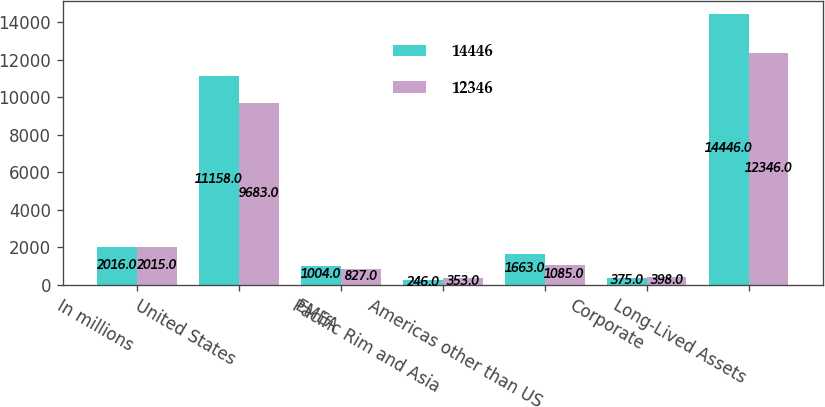Convert chart to OTSL. <chart><loc_0><loc_0><loc_500><loc_500><stacked_bar_chart><ecel><fcel>In millions<fcel>United States<fcel>EMEA<fcel>Pacific Rim and Asia<fcel>Americas other than US<fcel>Corporate<fcel>Long-Lived Assets<nl><fcel>14446<fcel>2016<fcel>11158<fcel>1004<fcel>246<fcel>1663<fcel>375<fcel>14446<nl><fcel>12346<fcel>2015<fcel>9683<fcel>827<fcel>353<fcel>1085<fcel>398<fcel>12346<nl></chart> 